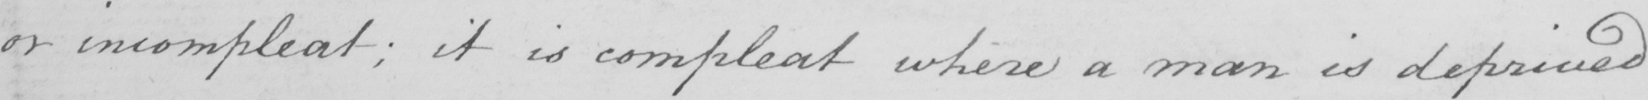Can you tell me what this handwritten text says? or incompleat:  it is compleat where a man is deprived 